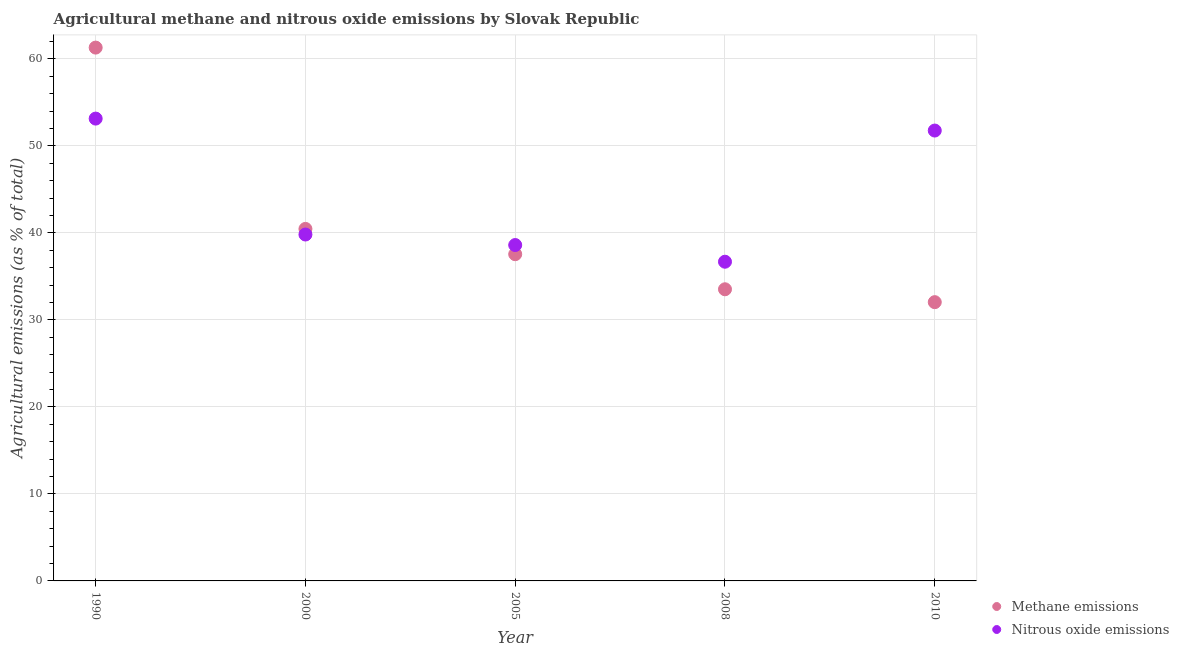How many different coloured dotlines are there?
Offer a terse response. 2. What is the amount of nitrous oxide emissions in 2005?
Your answer should be compact. 38.6. Across all years, what is the maximum amount of nitrous oxide emissions?
Offer a very short reply. 53.14. Across all years, what is the minimum amount of methane emissions?
Provide a succinct answer. 32.04. In which year was the amount of nitrous oxide emissions maximum?
Make the answer very short. 1990. In which year was the amount of methane emissions minimum?
Your answer should be very brief. 2010. What is the total amount of methane emissions in the graph?
Ensure brevity in your answer.  204.87. What is the difference between the amount of methane emissions in 2005 and that in 2010?
Provide a short and direct response. 5.51. What is the difference between the amount of nitrous oxide emissions in 1990 and the amount of methane emissions in 2000?
Provide a succinct answer. 12.68. What is the average amount of nitrous oxide emissions per year?
Offer a very short reply. 44. In the year 2010, what is the difference between the amount of methane emissions and amount of nitrous oxide emissions?
Your response must be concise. -19.72. What is the ratio of the amount of nitrous oxide emissions in 2008 to that in 2010?
Offer a very short reply. 0.71. Is the difference between the amount of methane emissions in 2005 and 2010 greater than the difference between the amount of nitrous oxide emissions in 2005 and 2010?
Provide a succinct answer. Yes. What is the difference between the highest and the second highest amount of nitrous oxide emissions?
Your response must be concise. 1.37. What is the difference between the highest and the lowest amount of nitrous oxide emissions?
Your answer should be very brief. 16.45. Is the amount of nitrous oxide emissions strictly less than the amount of methane emissions over the years?
Offer a very short reply. No. How many dotlines are there?
Ensure brevity in your answer.  2. How many years are there in the graph?
Your answer should be very brief. 5. What is the difference between two consecutive major ticks on the Y-axis?
Give a very brief answer. 10. How many legend labels are there?
Give a very brief answer. 2. What is the title of the graph?
Your answer should be very brief. Agricultural methane and nitrous oxide emissions by Slovak Republic. What is the label or title of the Y-axis?
Make the answer very short. Agricultural emissions (as % of total). What is the Agricultural emissions (as % of total) in Methane emissions in 1990?
Provide a succinct answer. 61.3. What is the Agricultural emissions (as % of total) of Nitrous oxide emissions in 1990?
Provide a succinct answer. 53.14. What is the Agricultural emissions (as % of total) in Methane emissions in 2000?
Your answer should be compact. 40.46. What is the Agricultural emissions (as % of total) in Nitrous oxide emissions in 2000?
Keep it short and to the point. 39.81. What is the Agricultural emissions (as % of total) in Methane emissions in 2005?
Ensure brevity in your answer.  37.55. What is the Agricultural emissions (as % of total) of Nitrous oxide emissions in 2005?
Provide a short and direct response. 38.6. What is the Agricultural emissions (as % of total) of Methane emissions in 2008?
Provide a short and direct response. 33.52. What is the Agricultural emissions (as % of total) in Nitrous oxide emissions in 2008?
Your answer should be compact. 36.69. What is the Agricultural emissions (as % of total) of Methane emissions in 2010?
Provide a succinct answer. 32.04. What is the Agricultural emissions (as % of total) of Nitrous oxide emissions in 2010?
Provide a short and direct response. 51.76. Across all years, what is the maximum Agricultural emissions (as % of total) in Methane emissions?
Provide a short and direct response. 61.3. Across all years, what is the maximum Agricultural emissions (as % of total) in Nitrous oxide emissions?
Make the answer very short. 53.14. Across all years, what is the minimum Agricultural emissions (as % of total) of Methane emissions?
Your answer should be compact. 32.04. Across all years, what is the minimum Agricultural emissions (as % of total) of Nitrous oxide emissions?
Ensure brevity in your answer.  36.69. What is the total Agricultural emissions (as % of total) in Methane emissions in the graph?
Provide a short and direct response. 204.87. What is the total Agricultural emissions (as % of total) in Nitrous oxide emissions in the graph?
Make the answer very short. 220. What is the difference between the Agricultural emissions (as % of total) in Methane emissions in 1990 and that in 2000?
Provide a succinct answer. 20.84. What is the difference between the Agricultural emissions (as % of total) in Nitrous oxide emissions in 1990 and that in 2000?
Offer a terse response. 13.32. What is the difference between the Agricultural emissions (as % of total) of Methane emissions in 1990 and that in 2005?
Provide a short and direct response. 23.75. What is the difference between the Agricultural emissions (as % of total) of Nitrous oxide emissions in 1990 and that in 2005?
Provide a succinct answer. 14.53. What is the difference between the Agricultural emissions (as % of total) in Methane emissions in 1990 and that in 2008?
Offer a terse response. 27.78. What is the difference between the Agricultural emissions (as % of total) in Nitrous oxide emissions in 1990 and that in 2008?
Provide a succinct answer. 16.45. What is the difference between the Agricultural emissions (as % of total) in Methane emissions in 1990 and that in 2010?
Offer a very short reply. 29.26. What is the difference between the Agricultural emissions (as % of total) in Nitrous oxide emissions in 1990 and that in 2010?
Your answer should be compact. 1.37. What is the difference between the Agricultural emissions (as % of total) of Methane emissions in 2000 and that in 2005?
Offer a terse response. 2.91. What is the difference between the Agricultural emissions (as % of total) in Nitrous oxide emissions in 2000 and that in 2005?
Provide a succinct answer. 1.21. What is the difference between the Agricultural emissions (as % of total) in Methane emissions in 2000 and that in 2008?
Offer a very short reply. 6.94. What is the difference between the Agricultural emissions (as % of total) of Nitrous oxide emissions in 2000 and that in 2008?
Provide a short and direct response. 3.13. What is the difference between the Agricultural emissions (as % of total) of Methane emissions in 2000 and that in 2010?
Your response must be concise. 8.42. What is the difference between the Agricultural emissions (as % of total) of Nitrous oxide emissions in 2000 and that in 2010?
Make the answer very short. -11.95. What is the difference between the Agricultural emissions (as % of total) in Methane emissions in 2005 and that in 2008?
Your response must be concise. 4.03. What is the difference between the Agricultural emissions (as % of total) of Nitrous oxide emissions in 2005 and that in 2008?
Make the answer very short. 1.92. What is the difference between the Agricultural emissions (as % of total) in Methane emissions in 2005 and that in 2010?
Keep it short and to the point. 5.51. What is the difference between the Agricultural emissions (as % of total) of Nitrous oxide emissions in 2005 and that in 2010?
Provide a short and direct response. -13.16. What is the difference between the Agricultural emissions (as % of total) of Methane emissions in 2008 and that in 2010?
Your response must be concise. 1.48. What is the difference between the Agricultural emissions (as % of total) of Nitrous oxide emissions in 2008 and that in 2010?
Provide a short and direct response. -15.08. What is the difference between the Agricultural emissions (as % of total) of Methane emissions in 1990 and the Agricultural emissions (as % of total) of Nitrous oxide emissions in 2000?
Offer a very short reply. 21.48. What is the difference between the Agricultural emissions (as % of total) in Methane emissions in 1990 and the Agricultural emissions (as % of total) in Nitrous oxide emissions in 2005?
Your answer should be very brief. 22.69. What is the difference between the Agricultural emissions (as % of total) in Methane emissions in 1990 and the Agricultural emissions (as % of total) in Nitrous oxide emissions in 2008?
Your answer should be compact. 24.61. What is the difference between the Agricultural emissions (as % of total) in Methane emissions in 1990 and the Agricultural emissions (as % of total) in Nitrous oxide emissions in 2010?
Give a very brief answer. 9.53. What is the difference between the Agricultural emissions (as % of total) of Methane emissions in 2000 and the Agricultural emissions (as % of total) of Nitrous oxide emissions in 2005?
Your response must be concise. 1.85. What is the difference between the Agricultural emissions (as % of total) in Methane emissions in 2000 and the Agricultural emissions (as % of total) in Nitrous oxide emissions in 2008?
Provide a succinct answer. 3.77. What is the difference between the Agricultural emissions (as % of total) in Methane emissions in 2000 and the Agricultural emissions (as % of total) in Nitrous oxide emissions in 2010?
Make the answer very short. -11.31. What is the difference between the Agricultural emissions (as % of total) of Methane emissions in 2005 and the Agricultural emissions (as % of total) of Nitrous oxide emissions in 2008?
Your answer should be compact. 0.86. What is the difference between the Agricultural emissions (as % of total) in Methane emissions in 2005 and the Agricultural emissions (as % of total) in Nitrous oxide emissions in 2010?
Your answer should be very brief. -14.21. What is the difference between the Agricultural emissions (as % of total) in Methane emissions in 2008 and the Agricultural emissions (as % of total) in Nitrous oxide emissions in 2010?
Provide a succinct answer. -18.24. What is the average Agricultural emissions (as % of total) of Methane emissions per year?
Make the answer very short. 40.97. What is the average Agricultural emissions (as % of total) of Nitrous oxide emissions per year?
Offer a very short reply. 44. In the year 1990, what is the difference between the Agricultural emissions (as % of total) in Methane emissions and Agricultural emissions (as % of total) in Nitrous oxide emissions?
Make the answer very short. 8.16. In the year 2000, what is the difference between the Agricultural emissions (as % of total) in Methane emissions and Agricultural emissions (as % of total) in Nitrous oxide emissions?
Give a very brief answer. 0.64. In the year 2005, what is the difference between the Agricultural emissions (as % of total) in Methane emissions and Agricultural emissions (as % of total) in Nitrous oxide emissions?
Your response must be concise. -1.05. In the year 2008, what is the difference between the Agricultural emissions (as % of total) of Methane emissions and Agricultural emissions (as % of total) of Nitrous oxide emissions?
Offer a terse response. -3.17. In the year 2010, what is the difference between the Agricultural emissions (as % of total) in Methane emissions and Agricultural emissions (as % of total) in Nitrous oxide emissions?
Provide a succinct answer. -19.72. What is the ratio of the Agricultural emissions (as % of total) in Methane emissions in 1990 to that in 2000?
Ensure brevity in your answer.  1.52. What is the ratio of the Agricultural emissions (as % of total) of Nitrous oxide emissions in 1990 to that in 2000?
Keep it short and to the point. 1.33. What is the ratio of the Agricultural emissions (as % of total) of Methane emissions in 1990 to that in 2005?
Give a very brief answer. 1.63. What is the ratio of the Agricultural emissions (as % of total) of Nitrous oxide emissions in 1990 to that in 2005?
Make the answer very short. 1.38. What is the ratio of the Agricultural emissions (as % of total) in Methane emissions in 1990 to that in 2008?
Keep it short and to the point. 1.83. What is the ratio of the Agricultural emissions (as % of total) of Nitrous oxide emissions in 1990 to that in 2008?
Your response must be concise. 1.45. What is the ratio of the Agricultural emissions (as % of total) of Methane emissions in 1990 to that in 2010?
Provide a succinct answer. 1.91. What is the ratio of the Agricultural emissions (as % of total) in Nitrous oxide emissions in 1990 to that in 2010?
Your answer should be compact. 1.03. What is the ratio of the Agricultural emissions (as % of total) of Methane emissions in 2000 to that in 2005?
Keep it short and to the point. 1.08. What is the ratio of the Agricultural emissions (as % of total) of Nitrous oxide emissions in 2000 to that in 2005?
Your answer should be compact. 1.03. What is the ratio of the Agricultural emissions (as % of total) in Methane emissions in 2000 to that in 2008?
Give a very brief answer. 1.21. What is the ratio of the Agricultural emissions (as % of total) in Nitrous oxide emissions in 2000 to that in 2008?
Your answer should be compact. 1.09. What is the ratio of the Agricultural emissions (as % of total) of Methane emissions in 2000 to that in 2010?
Provide a short and direct response. 1.26. What is the ratio of the Agricultural emissions (as % of total) in Nitrous oxide emissions in 2000 to that in 2010?
Ensure brevity in your answer.  0.77. What is the ratio of the Agricultural emissions (as % of total) in Methane emissions in 2005 to that in 2008?
Your answer should be very brief. 1.12. What is the ratio of the Agricultural emissions (as % of total) in Nitrous oxide emissions in 2005 to that in 2008?
Give a very brief answer. 1.05. What is the ratio of the Agricultural emissions (as % of total) of Methane emissions in 2005 to that in 2010?
Provide a succinct answer. 1.17. What is the ratio of the Agricultural emissions (as % of total) in Nitrous oxide emissions in 2005 to that in 2010?
Provide a succinct answer. 0.75. What is the ratio of the Agricultural emissions (as % of total) of Methane emissions in 2008 to that in 2010?
Ensure brevity in your answer.  1.05. What is the ratio of the Agricultural emissions (as % of total) in Nitrous oxide emissions in 2008 to that in 2010?
Offer a very short reply. 0.71. What is the difference between the highest and the second highest Agricultural emissions (as % of total) in Methane emissions?
Make the answer very short. 20.84. What is the difference between the highest and the second highest Agricultural emissions (as % of total) of Nitrous oxide emissions?
Make the answer very short. 1.37. What is the difference between the highest and the lowest Agricultural emissions (as % of total) in Methane emissions?
Your answer should be very brief. 29.26. What is the difference between the highest and the lowest Agricultural emissions (as % of total) in Nitrous oxide emissions?
Offer a terse response. 16.45. 